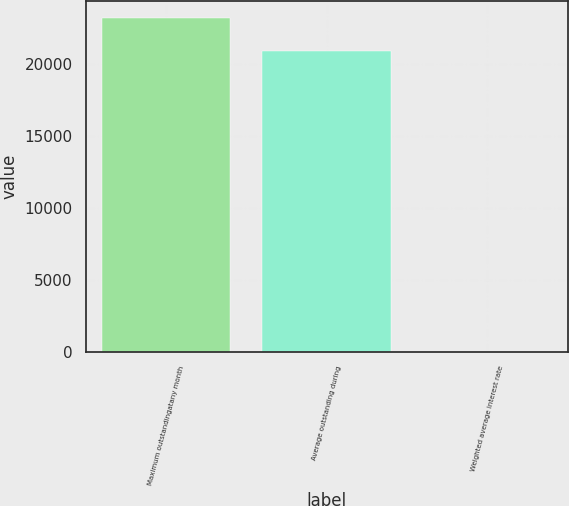Convert chart to OTSL. <chart><loc_0><loc_0><loc_500><loc_500><bar_chart><fcel>Maximum outstandingatany month<fcel>Average outstanding during<fcel>Weighted average interest rate<nl><fcel>23185<fcel>20883<fcel>4.38<nl></chart> 